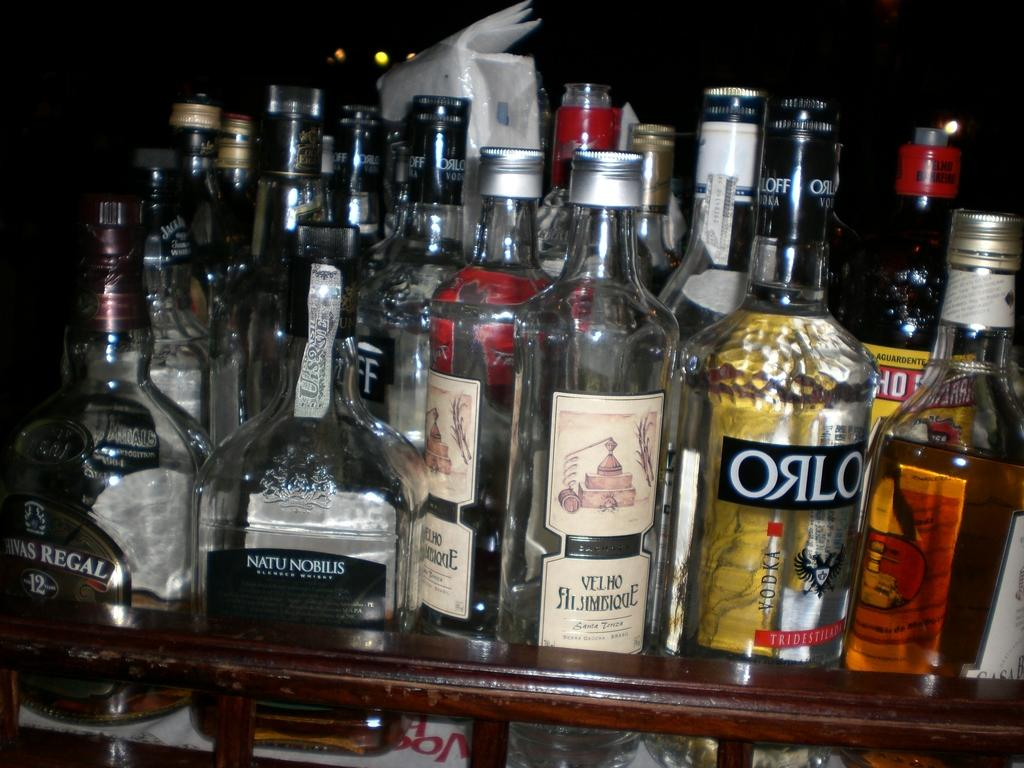Provide a one-sentence caption for the provided image. A bottle of Orlo sits among many other bottles. 